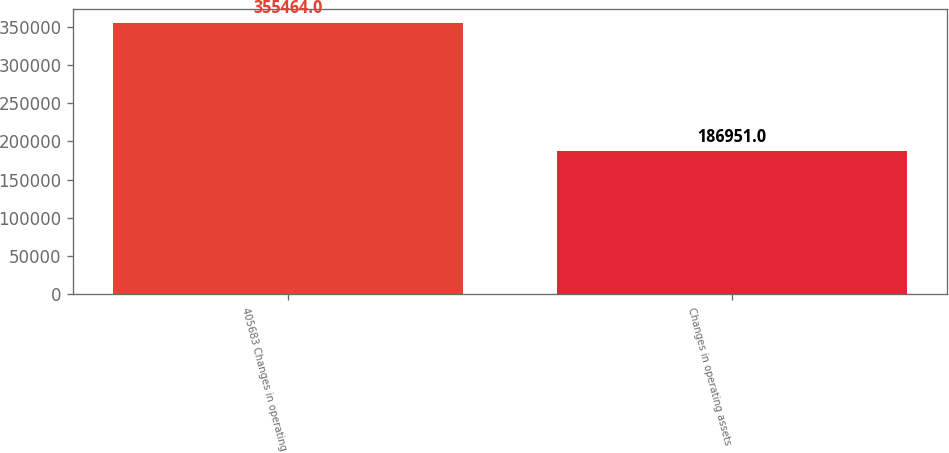Convert chart. <chart><loc_0><loc_0><loc_500><loc_500><bar_chart><fcel>405683 Changes in operating<fcel>Changes in operating assets<nl><fcel>355464<fcel>186951<nl></chart> 